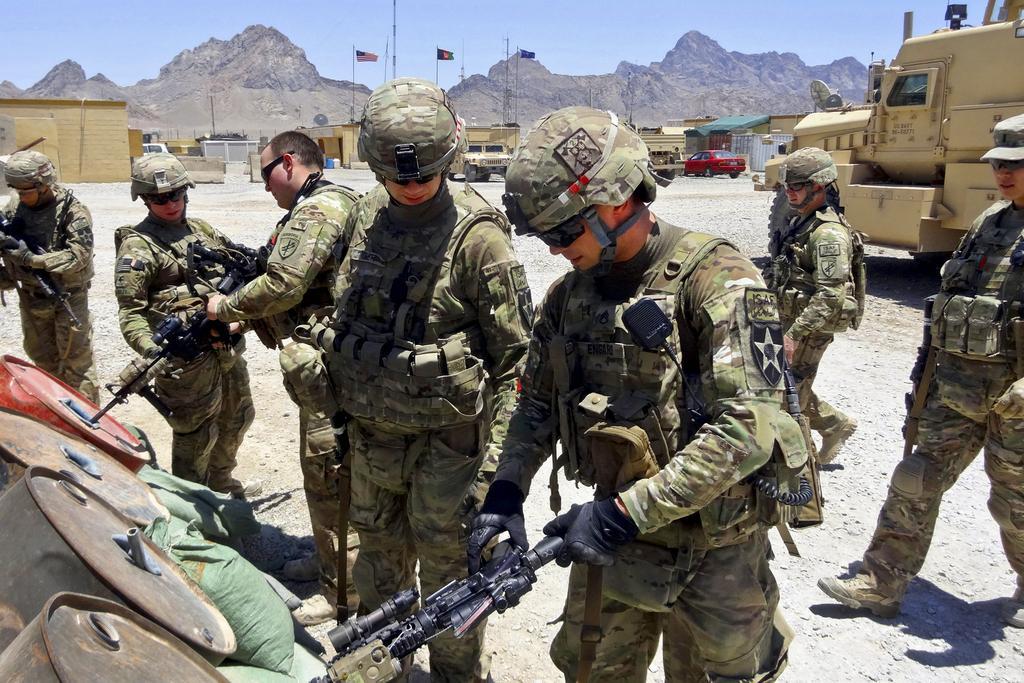Describe this image in one or two sentences. In the center of the image there are soldiers standing. In the background of the image there are mountains. There are flags. There are cars in the image. 